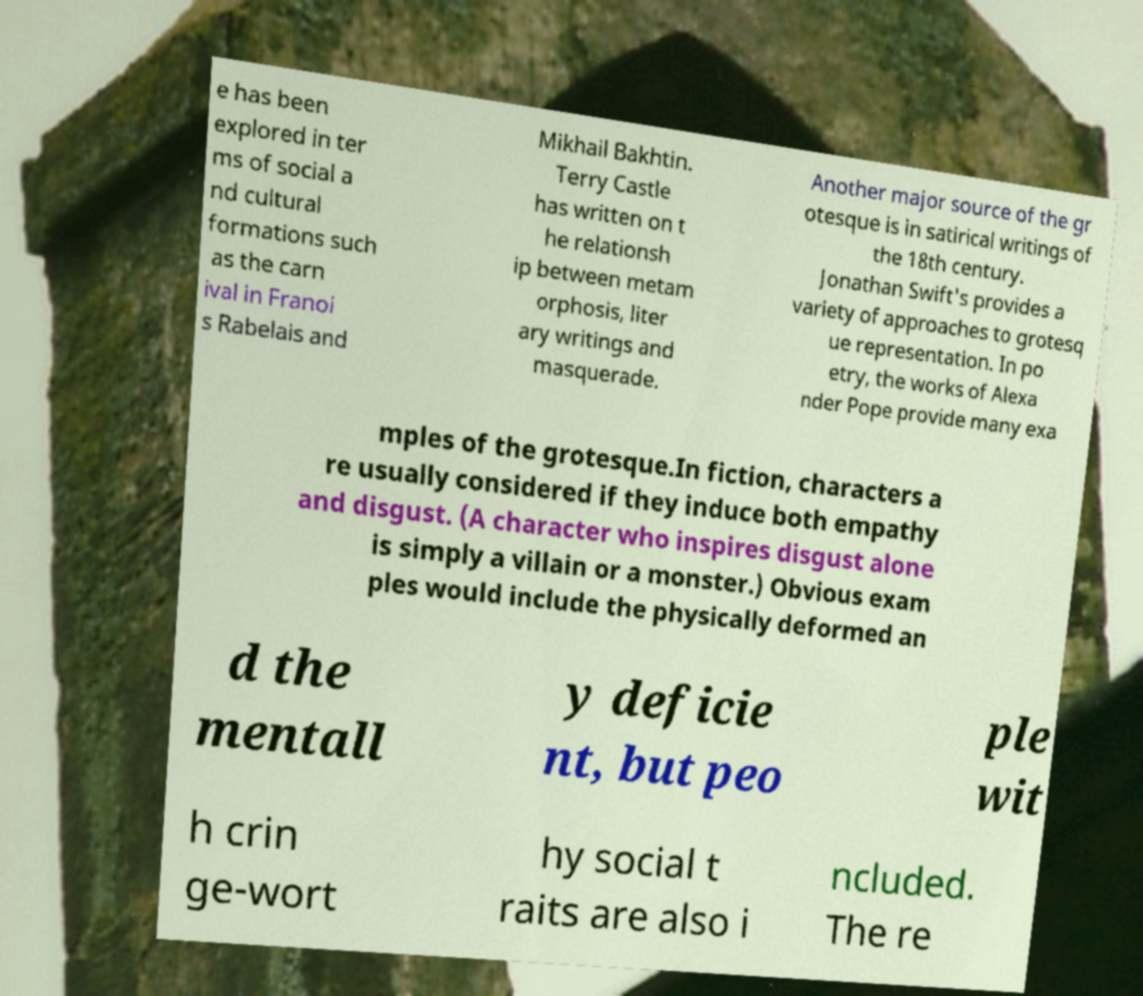Can you accurately transcribe the text from the provided image for me? e has been explored in ter ms of social a nd cultural formations such as the carn ival in Franoi s Rabelais and Mikhail Bakhtin. Terry Castle has written on t he relationsh ip between metam orphosis, liter ary writings and masquerade. Another major source of the gr otesque is in satirical writings of the 18th century. Jonathan Swift's provides a variety of approaches to grotesq ue representation. In po etry, the works of Alexa nder Pope provide many exa mples of the grotesque.In fiction, characters a re usually considered if they induce both empathy and disgust. (A character who inspires disgust alone is simply a villain or a monster.) Obvious exam ples would include the physically deformed an d the mentall y deficie nt, but peo ple wit h crin ge-wort hy social t raits are also i ncluded. The re 